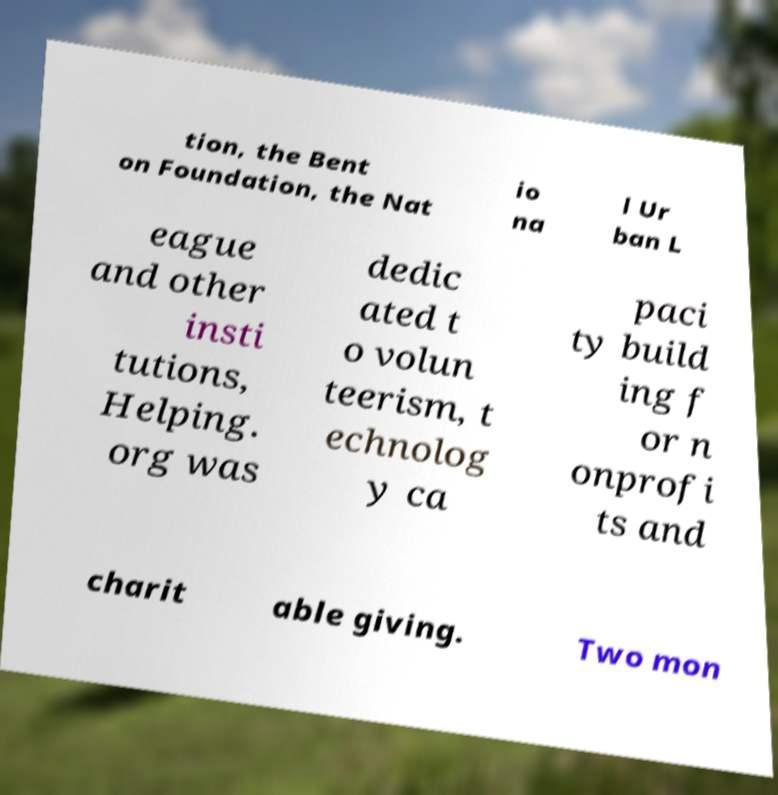Can you read and provide the text displayed in the image?This photo seems to have some interesting text. Can you extract and type it out for me? tion, the Bent on Foundation, the Nat io na l Ur ban L eague and other insti tutions, Helping. org was dedic ated t o volun teerism, t echnolog y ca paci ty build ing f or n onprofi ts and charit able giving. Two mon 